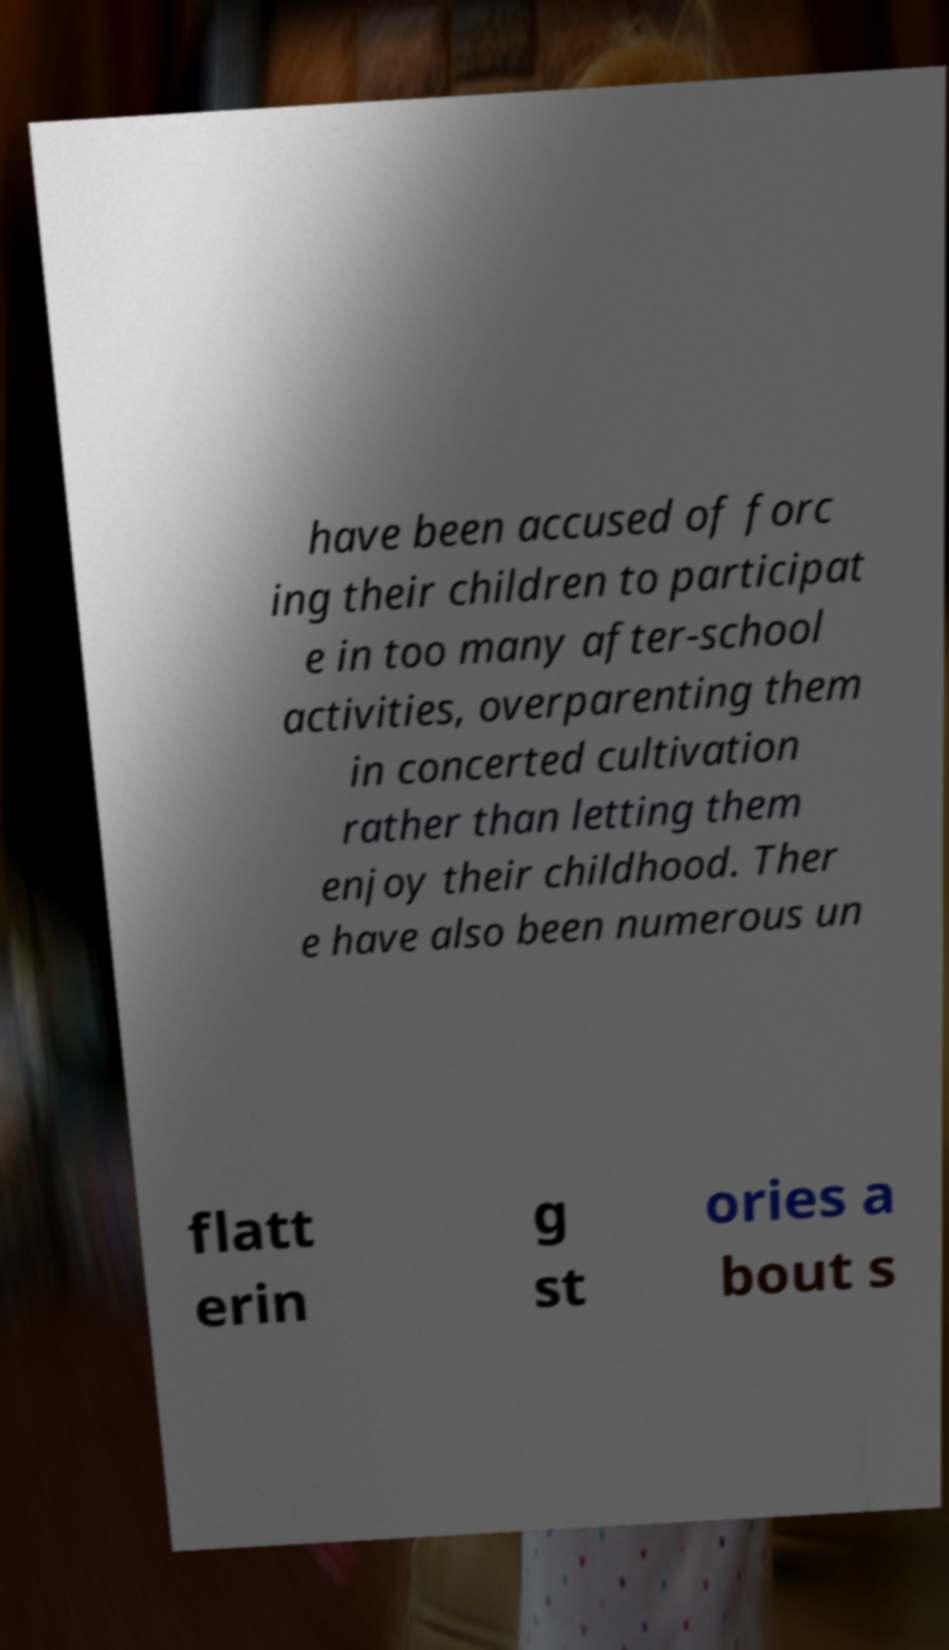Could you assist in decoding the text presented in this image and type it out clearly? have been accused of forc ing their children to participat e in too many after-school activities, overparenting them in concerted cultivation rather than letting them enjoy their childhood. Ther e have also been numerous un flatt erin g st ories a bout s 